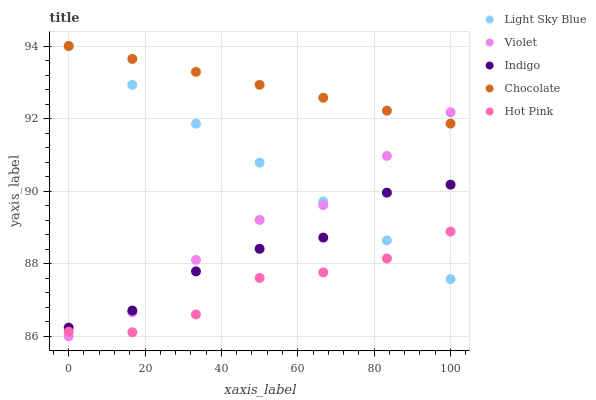Does Hot Pink have the minimum area under the curve?
Answer yes or no. Yes. Does Chocolate have the maximum area under the curve?
Answer yes or no. Yes. Does Light Sky Blue have the minimum area under the curve?
Answer yes or no. No. Does Light Sky Blue have the maximum area under the curve?
Answer yes or no. No. Is Light Sky Blue the smoothest?
Answer yes or no. Yes. Is Indigo the roughest?
Answer yes or no. Yes. Is Hot Pink the smoothest?
Answer yes or no. No. Is Hot Pink the roughest?
Answer yes or no. No. Does Violet have the lowest value?
Answer yes or no. Yes. Does Hot Pink have the lowest value?
Answer yes or no. No. Does Light Sky Blue have the highest value?
Answer yes or no. Yes. Does Hot Pink have the highest value?
Answer yes or no. No. Is Indigo less than Chocolate?
Answer yes or no. Yes. Is Chocolate greater than Indigo?
Answer yes or no. Yes. Does Light Sky Blue intersect Indigo?
Answer yes or no. Yes. Is Light Sky Blue less than Indigo?
Answer yes or no. No. Is Light Sky Blue greater than Indigo?
Answer yes or no. No. Does Indigo intersect Chocolate?
Answer yes or no. No. 